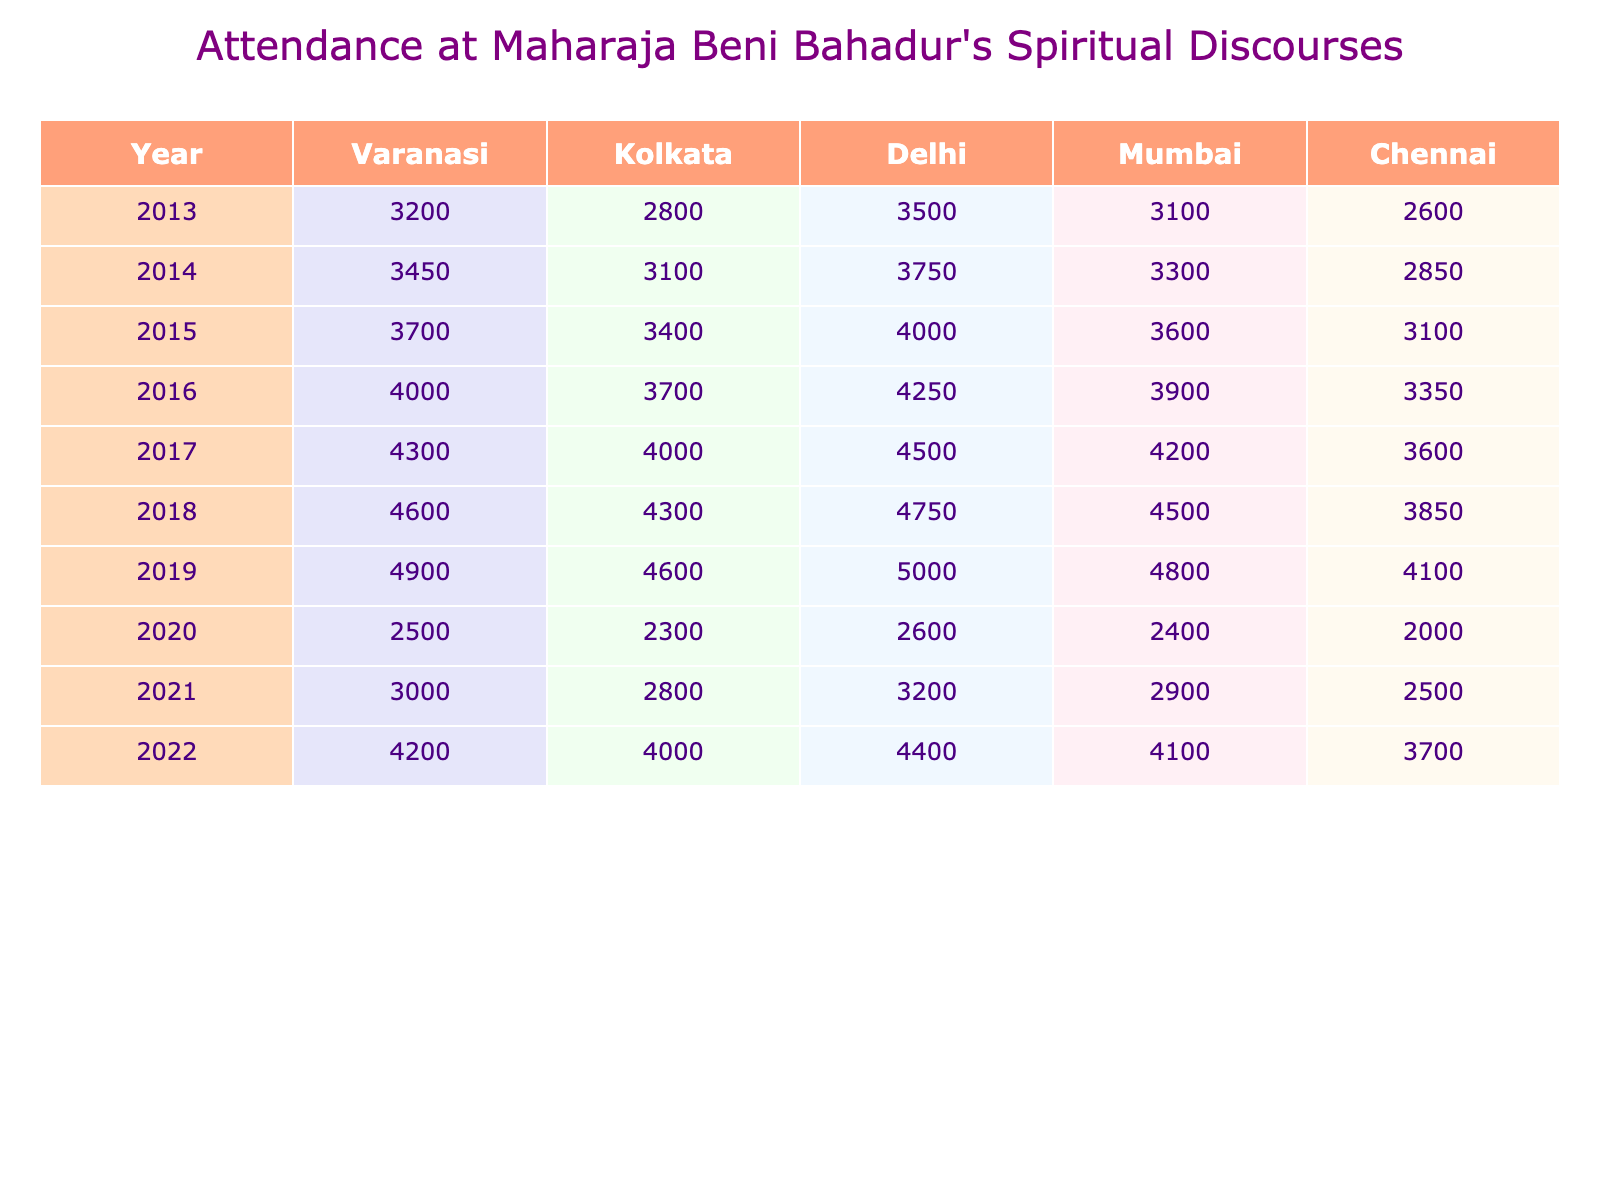What year had the highest attendance in Delhi? From the table, we look at the Delhi column across all years. The maximum value is 5000 in the year 2019.
Answer: 2019 Which city had the least attendance in 2020? In 2020, we check the attendance numbers for all cities: Varanasi (2500), Kolkata (2300), Delhi (2600), Mumbai (2400), and Chennai (2000). The least is in Chennai with 2000.
Answer: Chennai What was the total attendance in Mumbai over the years 2013 to 2022? We sum the attendance figures for Mumbai from 2013 to 2022: 3100 + 3300 + 3600 + 3900 + 4200 + 4500 + 4800 + 2900 + 4100 = 32100.
Answer: 32100 In which year did attendance in Varanasi first exceed 4000? We look through the Varanasi column: 3200 (2013), 3450 (2014), 3700 (2015), 4000 (2016), and then it exceeds 4000 in 2017 when it was 4300.
Answer: 2017 What is the average attendance in Chennai over the decade? To find the average, we sum the attendance figures: 2600 + 2850 + 3100 + 3350 + 3600 + 3850 + 4100 + 2500 + 3700 =  29600. Then, we divide this by the 9 years, which gives us an average of 29600 / 9 ≈ 3288.89.
Answer: ~3289 Was the attendance in Kolkata higher in 2019 or 2022? We compare the figures for Kolkata in those years: 4600 in 2019 and 4000 in 2022. 4600 is higher than 4000.
Answer: Yes Which city showed the greatest increase in attendance from 2013 to 2018? We check the values: Varanasi increased from 3200 to 4600 (1400 increase), Kolkata from 2800 to 4300 (1500 increase), Delhi from 3500 to 4750 (1250 increase), Mumbai from 3100 to 4500 (1400 increase), and Chennai from 2600 to 3850 (1250 increase). The greatest increase is in Kolkata with 1500.
Answer: Kolkata How much lower was the 2020 attendance in Chennai compared to 2019? Attendance in Chennai in 2019 was 4100 and in 2020 was 2000. The difference is 4100 - 2000 = 2100.
Answer: 2100 What was the overall trend of attendance from 2013 to 2019 in Varanasi? Over the years 2013 to 2019, the attendance in Varanasi increased from 3200 to 4900, which indicates an upward trend over these years.
Answer: Upward trend Is there a year when attendance in Delhi was exactly the same as in Kolkata? Looking at the values, in 2014 and 2015, the attendance numbers were 3100 and 3400 respectively in both cities, but they were not equal at any time.
Answer: No 